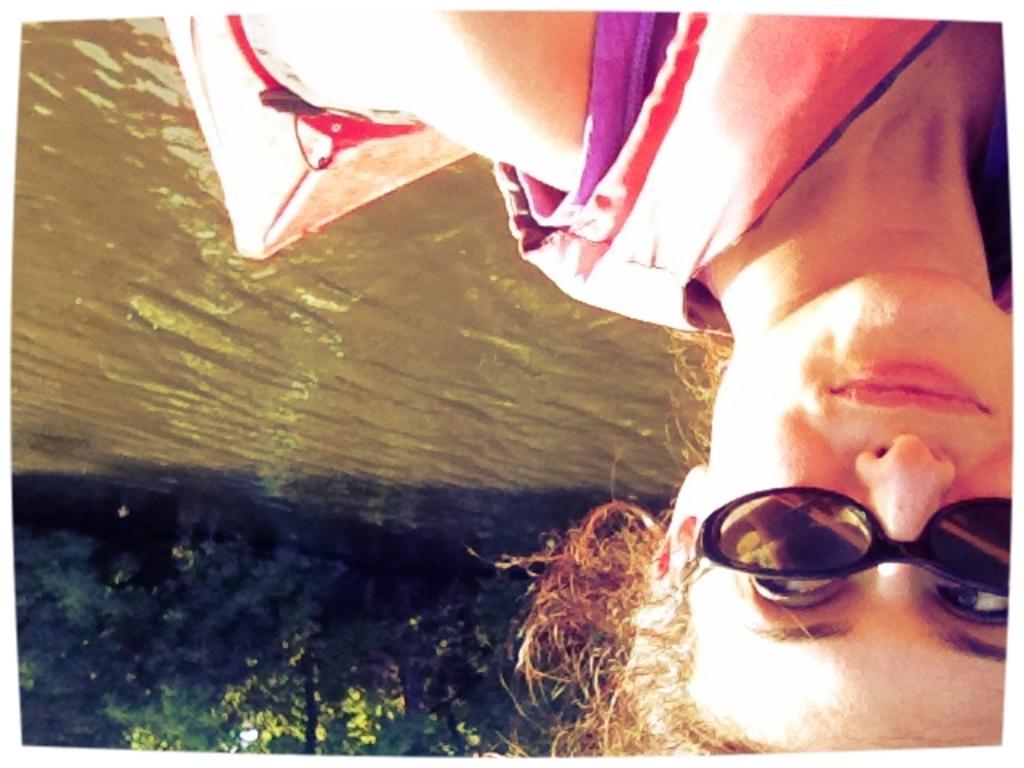In one or two sentences, can you explain what this image depicts? In this picture there is a woman smiling and we can see boat above the water and trees. 